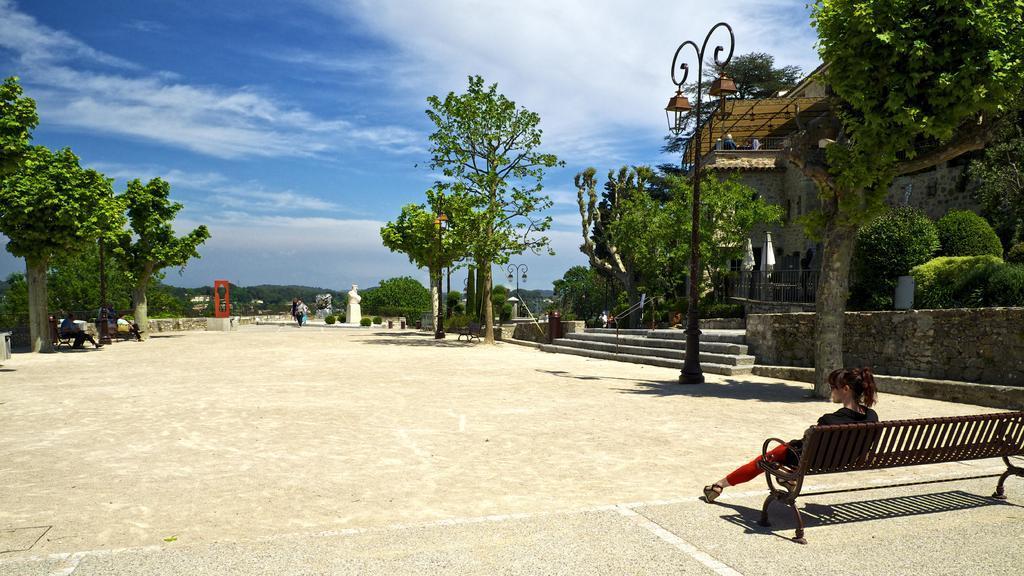Can you describe this image briefly? This image is taken in outdoors. In the middle of the image there is a ground. In the right side of the image there is a bench and a girl is sitting on it and in the right side of the image there were few plants and trees and a house with walls and windows, a railing and a street light. At the top of the image there is a sky with clouds. At the background there are many trees. 